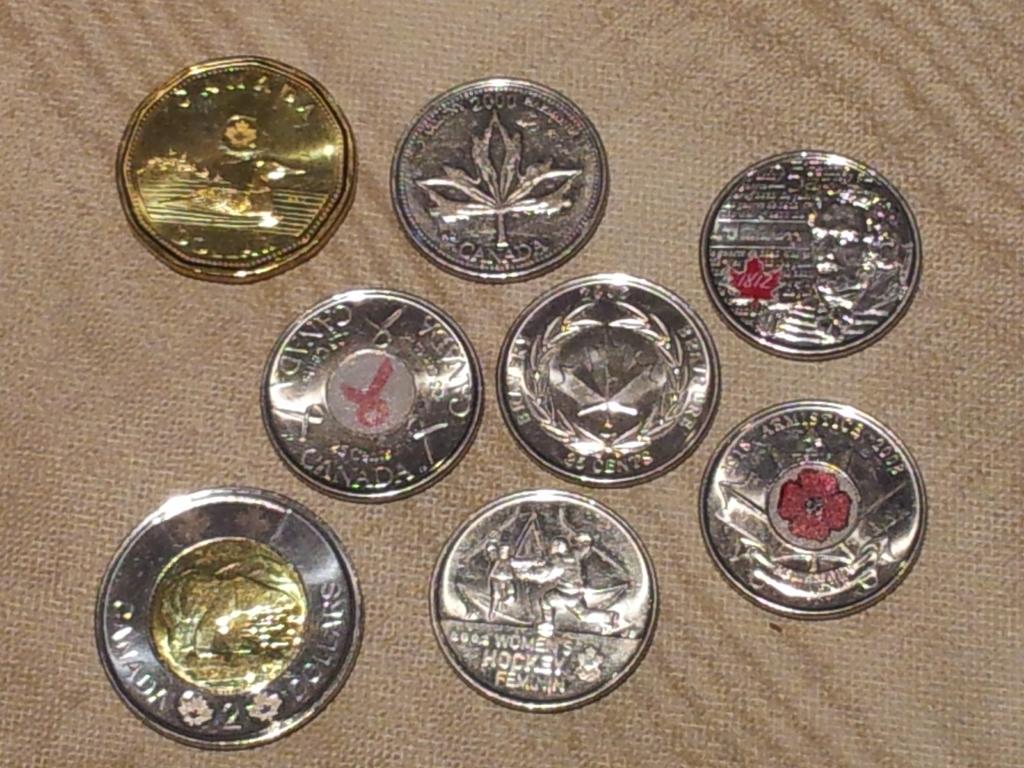What country are these coins from?
Offer a terse response. Canada. Are these coins canadian?
Provide a short and direct response. Yes. 